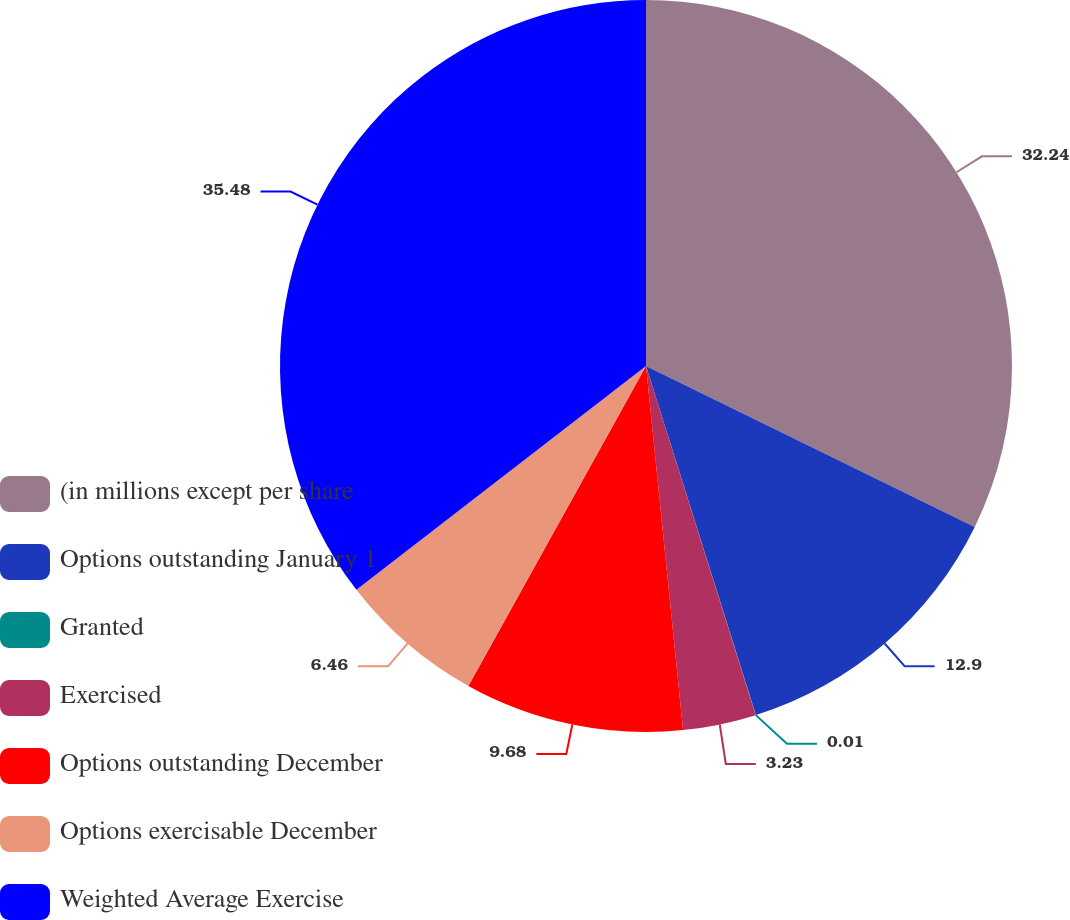Convert chart to OTSL. <chart><loc_0><loc_0><loc_500><loc_500><pie_chart><fcel>(in millions except per share<fcel>Options outstanding January 1<fcel>Granted<fcel>Exercised<fcel>Options outstanding December<fcel>Options exercisable December<fcel>Weighted Average Exercise<nl><fcel>32.24%<fcel>12.9%<fcel>0.01%<fcel>3.23%<fcel>9.68%<fcel>6.46%<fcel>35.47%<nl></chart> 